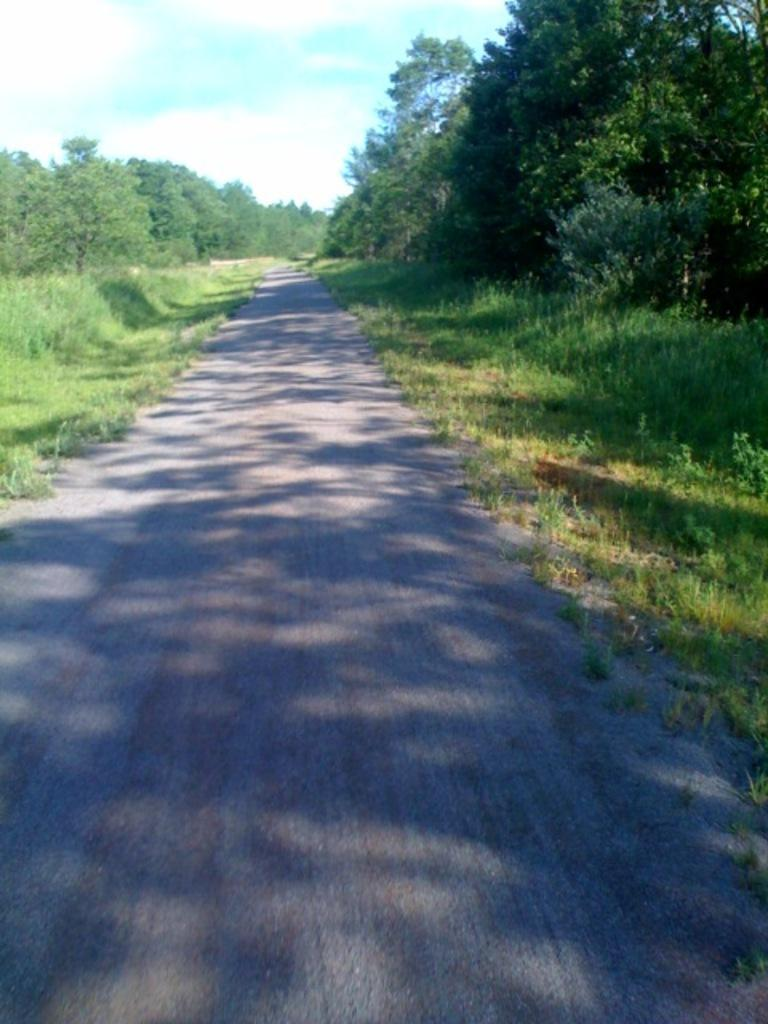What is the main feature of the image? There is a road in the image. What can be seen on the left side of the image? There are trees on the left side of the image. What can be seen on the right side of the image? There are trees on the right side of the image. What type of vegetation is present in the image? There are plants in the image. What is visible at the top of the image? The sky is visible at the top of the image. Can you tell me how many aunts are walking their horses along the road in the image? There are no aunts or horses present in the image; it only features a road, trees, plants, and the sky. 